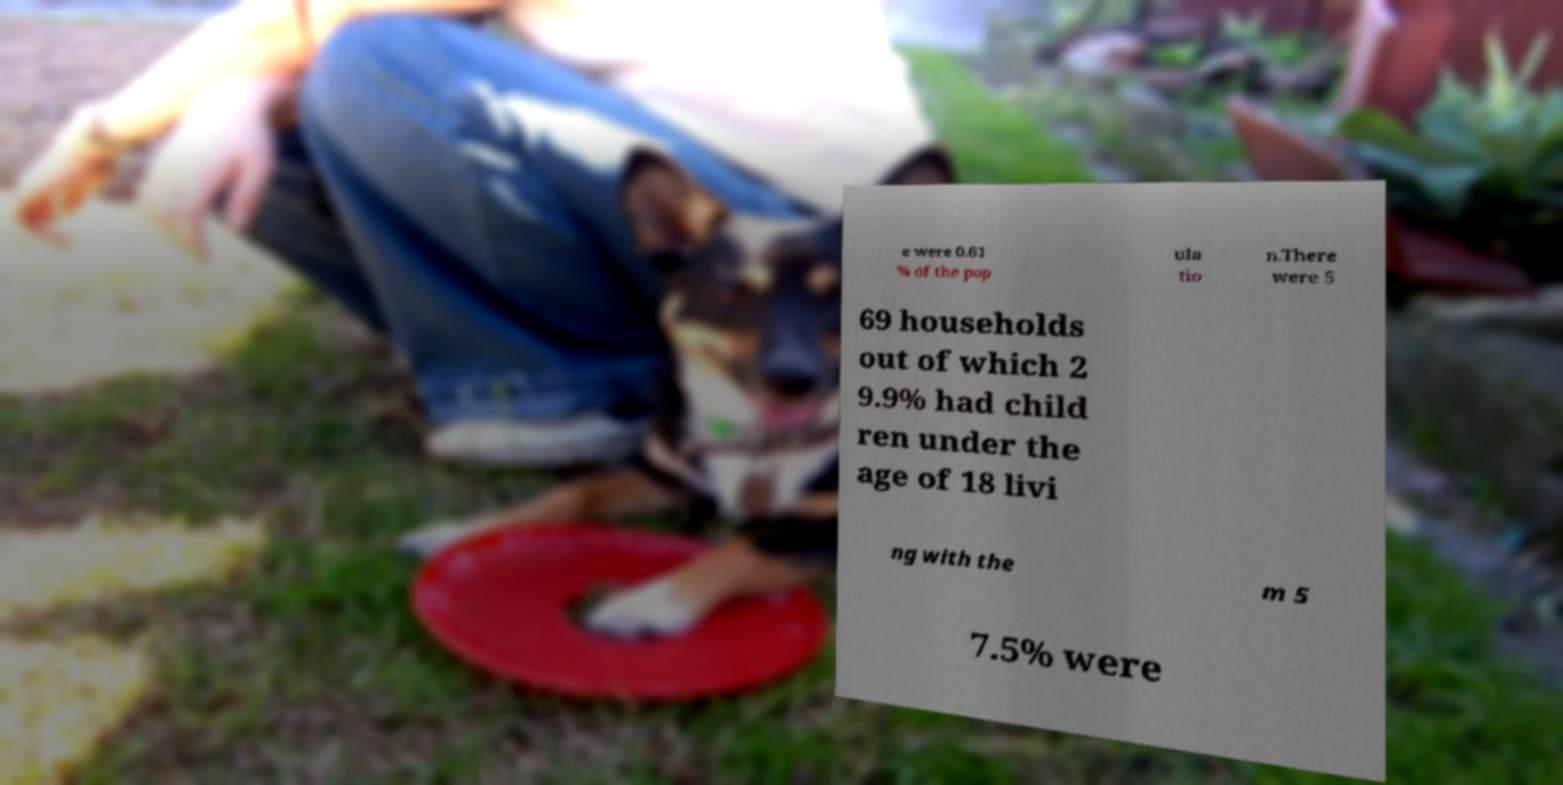Can you accurately transcribe the text from the provided image for me? e were 0.61 % of the pop ula tio n.There were 5 69 households out of which 2 9.9% had child ren under the age of 18 livi ng with the m 5 7.5% were 